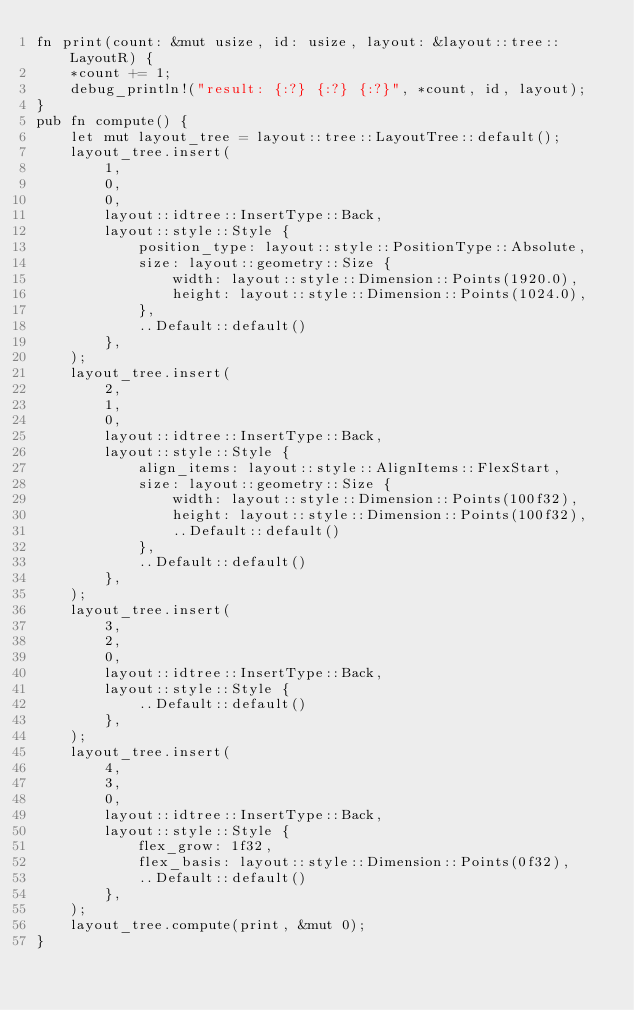Convert code to text. <code><loc_0><loc_0><loc_500><loc_500><_Rust_>fn print(count: &mut usize, id: usize, layout: &layout::tree::LayoutR) {
    *count += 1;
    debug_println!("result: {:?} {:?} {:?}", *count, id, layout);
}
pub fn compute() {
    let mut layout_tree = layout::tree::LayoutTree::default();
    layout_tree.insert(
        1,
        0,
        0,
        layout::idtree::InsertType::Back,
        layout::style::Style {
            position_type: layout::style::PositionType::Absolute,
            size: layout::geometry::Size {
                width: layout::style::Dimension::Points(1920.0),
                height: layout::style::Dimension::Points(1024.0),
            },
            ..Default::default()
        },
    );
    layout_tree.insert(
        2,
        1,
        0,
        layout::idtree::InsertType::Back,
        layout::style::Style {
            align_items: layout::style::AlignItems::FlexStart,
            size: layout::geometry::Size {
                width: layout::style::Dimension::Points(100f32),
                height: layout::style::Dimension::Points(100f32),
                ..Default::default()
            },
            ..Default::default()
        },
    );
    layout_tree.insert(
        3,
        2,
        0,
        layout::idtree::InsertType::Back,
        layout::style::Style {
            ..Default::default()
        },
    );
    layout_tree.insert(
        4,
        3,
        0,
        layout::idtree::InsertType::Back,
        layout::style::Style {
            flex_grow: 1f32,
            flex_basis: layout::style::Dimension::Points(0f32),
            ..Default::default()
        },
    );
    layout_tree.compute(print, &mut 0);
}
</code> 